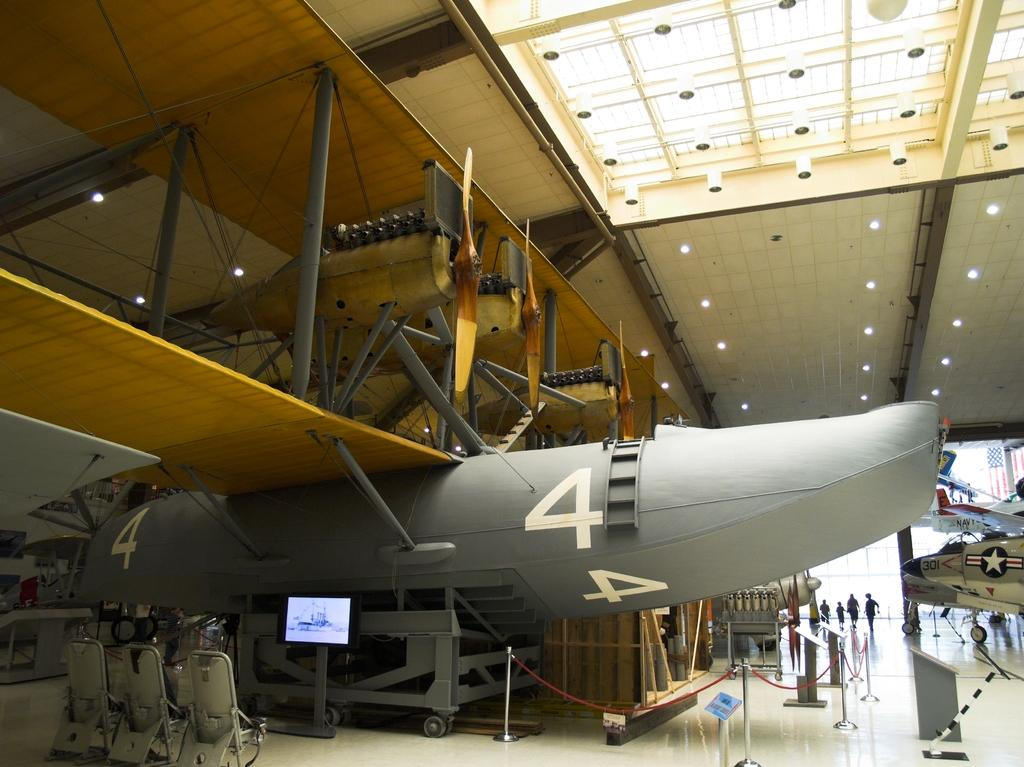Provide a one-sentence caption for the provided image. Gray airplane with number four engraved in white. 